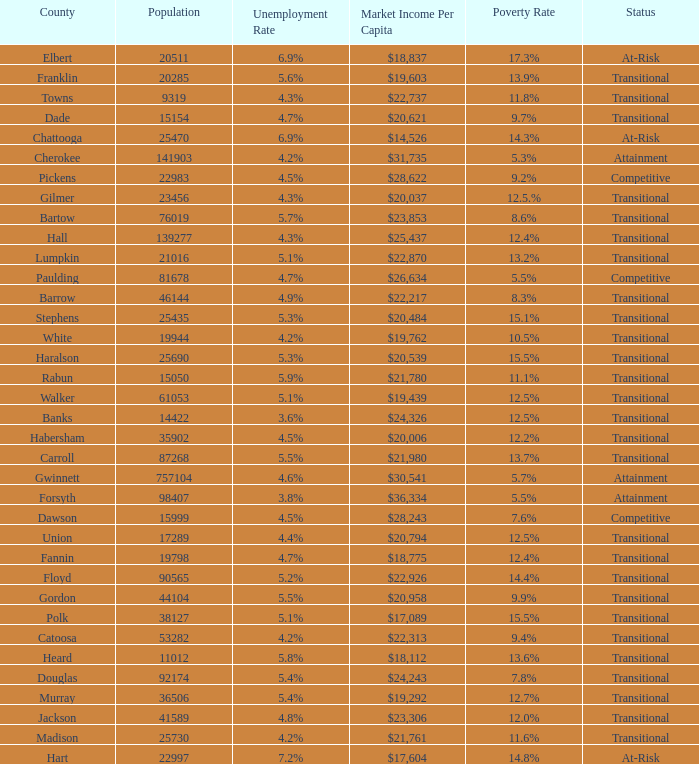What is the status of the county with per capita market income of $24,326? Transitional. 